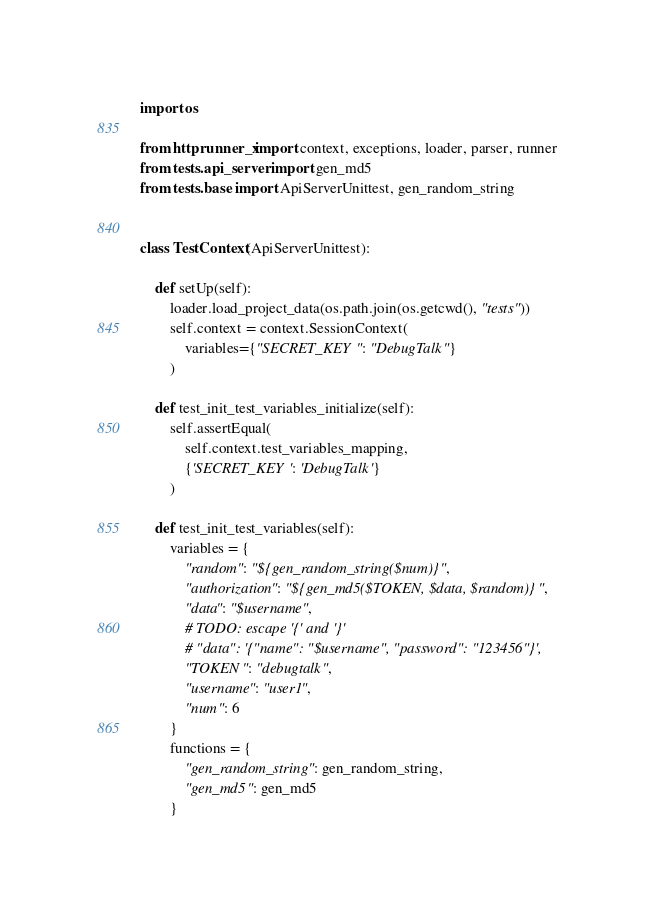<code> <loc_0><loc_0><loc_500><loc_500><_Python_>import os

from httprunner_x import context, exceptions, loader, parser, runner
from tests.api_server import gen_md5
from tests.base import ApiServerUnittest, gen_random_string


class TestContext(ApiServerUnittest):

    def setUp(self):
        loader.load_project_data(os.path.join(os.getcwd(), "tests"))
        self.context = context.SessionContext(
            variables={"SECRET_KEY": "DebugTalk"}
        )

    def test_init_test_variables_initialize(self):
        self.assertEqual(
            self.context.test_variables_mapping,
            {'SECRET_KEY': 'DebugTalk'}
        )

    def test_init_test_variables(self):
        variables = {
            "random": "${gen_random_string($num)}",
            "authorization": "${gen_md5($TOKEN, $data, $random)}",
            "data": "$username",
            # TODO: escape '{' and '}'
            # "data": '{"name": "$username", "password": "123456"}',
            "TOKEN": "debugtalk",
            "username": "user1",
            "num": 6
        }
        functions = {
            "gen_random_string": gen_random_string,
            "gen_md5": gen_md5
        }</code> 